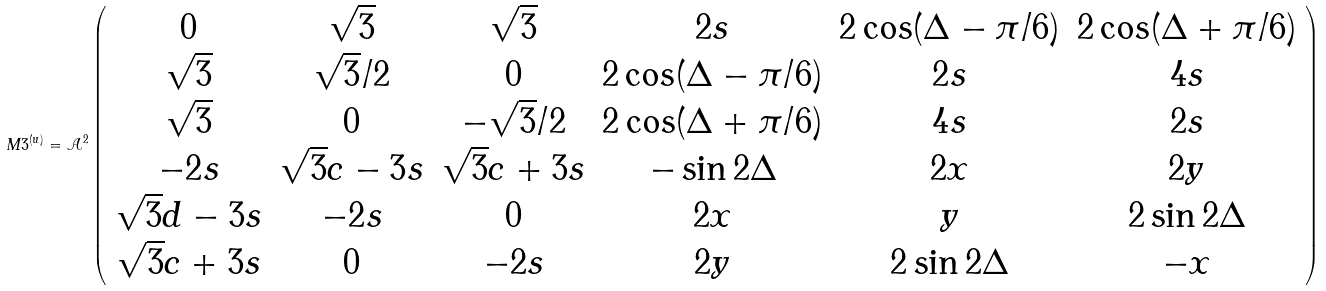Convert formula to latex. <formula><loc_0><loc_0><loc_500><loc_500>M 3 ^ { ( u ) } = \mathcal { A } ^ { 2 } \left ( \begin{array} { c c c c c c } 0 & \sqrt { 3 } & \sqrt { 3 } & 2 s & 2 \cos ( \Delta - \pi / 6 ) & 2 \cos ( \Delta + \pi / 6 ) \\ \sqrt { 3 } & \sqrt { 3 } / 2 & 0 & 2 \cos ( \Delta - \pi / 6 ) & 2 s & 4 s \\ \sqrt { 3 } & 0 & - \sqrt { 3 } / 2 & 2 \cos ( \Delta + \pi / 6 ) & 4 s & 2 s \\ - 2 s & \sqrt { 3 } c - 3 s & \sqrt { 3 } c + 3 s & - \sin 2 \Delta & 2 x & 2 y \\ \sqrt { 3 } d - 3 s & - 2 s & 0 & 2 x & y & 2 \sin 2 \Delta \\ \sqrt { 3 } c + 3 s & 0 & - 2 s & 2 y & 2 \sin 2 \Delta & - x \end{array} \right )</formula> 